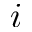<formula> <loc_0><loc_0><loc_500><loc_500>i</formula> 